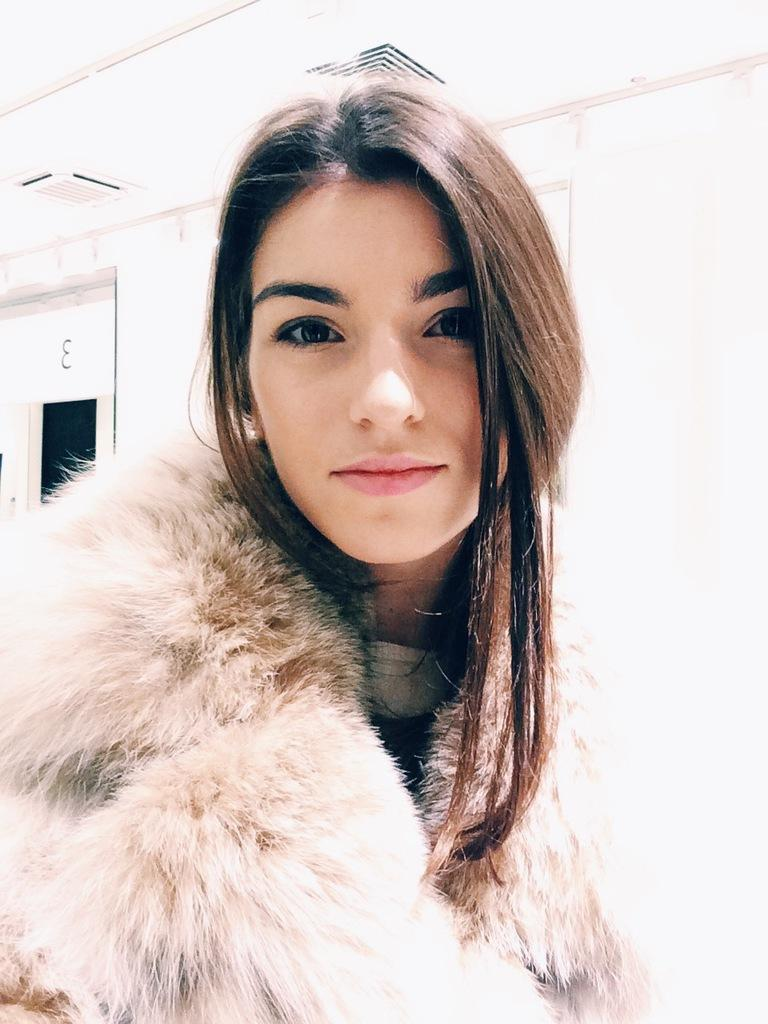Who is the main subject in the foreground of the image? There is a woman in the foreground of the image. What can be seen in the background of the image? There is a white wall and a ceiling visible in the background of the image. Can you describe the architectural feature on the left side of the image? There appears to be a door on the left side of the image. What type of linen is draped over the town in the image? There is no town or linen present in the image. What is the weather like in the image? The provided facts do not mention the weather, so it cannot be determined from the image. 